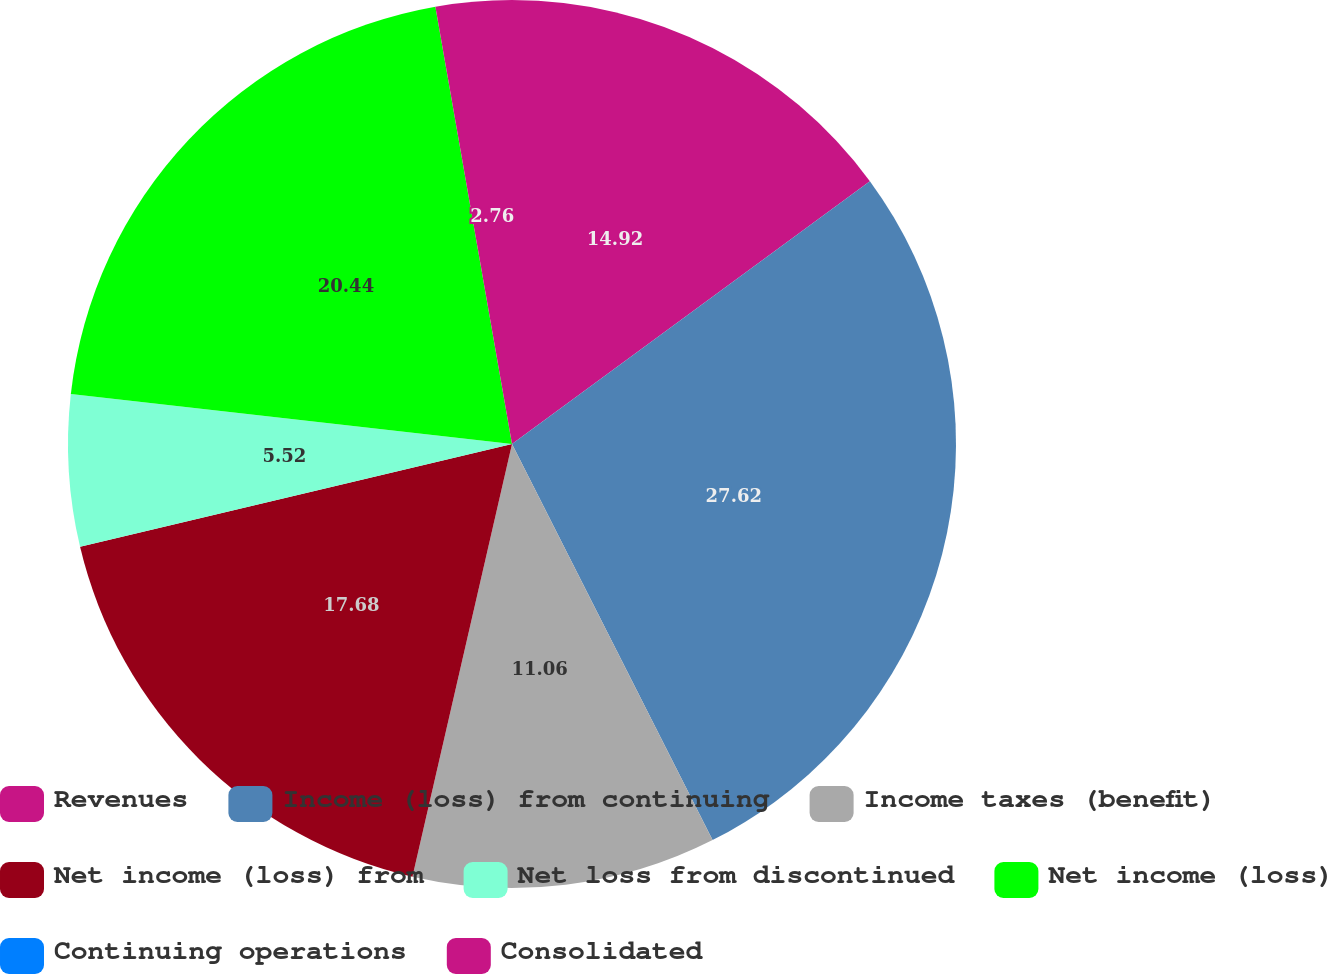Convert chart. <chart><loc_0><loc_0><loc_500><loc_500><pie_chart><fcel>Revenues<fcel>Income (loss) from continuing<fcel>Income taxes (benefit)<fcel>Net income (loss) from<fcel>Net loss from discontinued<fcel>Net income (loss)<fcel>Continuing operations<fcel>Consolidated<nl><fcel>14.92%<fcel>27.62%<fcel>11.06%<fcel>17.68%<fcel>5.52%<fcel>20.44%<fcel>0.0%<fcel>2.76%<nl></chart> 